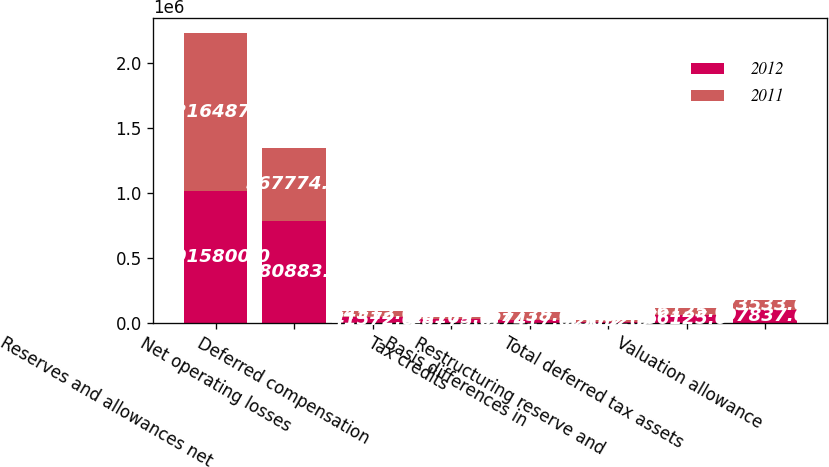<chart> <loc_0><loc_0><loc_500><loc_500><stacked_bar_chart><ecel><fcel>Reserves and allowances net<fcel>Net operating losses<fcel>Deferred compensation<fcel>Tax credits<fcel>Basis differences in<fcel>Restructuring reserve and<fcel>Total deferred tax assets<fcel>Valuation allowance<nl><fcel>2012<fcel>1.0158e+06<fcel>780883<fcel>41572<fcel>28775<fcel>17417<fcel>2162<fcel>56125<fcel>97837<nl><fcel>2011<fcel>1.21649e+06<fcel>567774<fcel>44512<fcel>16169<fcel>67738<fcel>15092<fcel>56125<fcel>73533<nl></chart> 